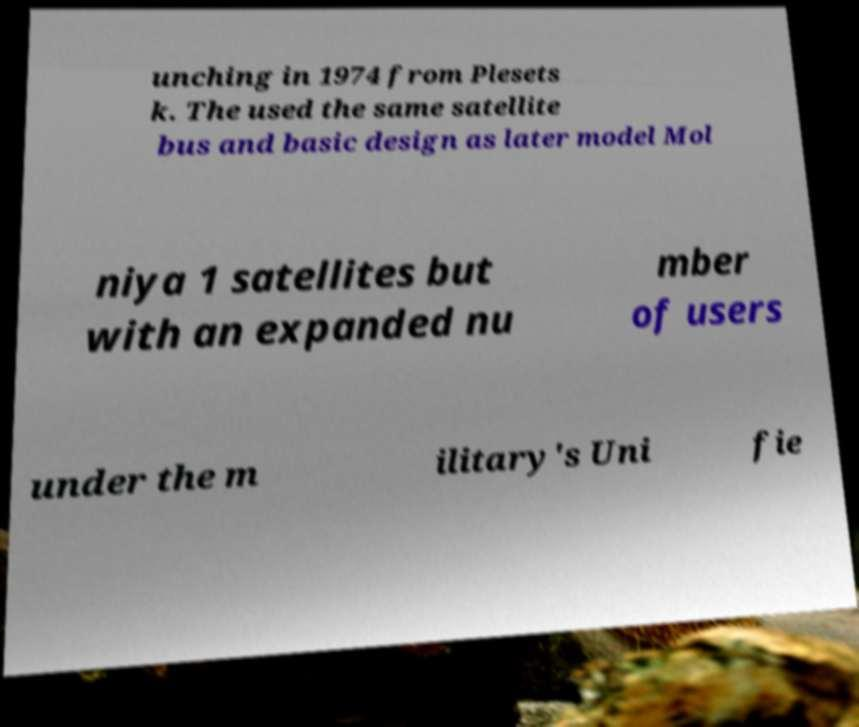Could you extract and type out the text from this image? unching in 1974 from Plesets k. The used the same satellite bus and basic design as later model Mol niya 1 satellites but with an expanded nu mber of users under the m ilitary's Uni fie 